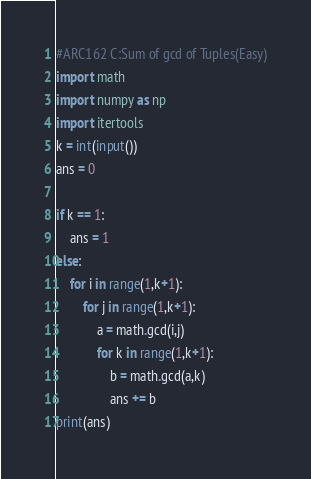<code> <loc_0><loc_0><loc_500><loc_500><_Python_>#ARC162 C:Sum of gcd of Tuples(Easy)
import math
import numpy as np
import itertools
k = int(input())
ans = 0

if k == 1:
    ans = 1
else:
    for i in range(1,k+1):
        for j in range(1,k+1):
            a = math.gcd(i,j)
            for k in range(1,k+1):
                b = math.gcd(a,k)
                ans += b    
print(ans)</code> 